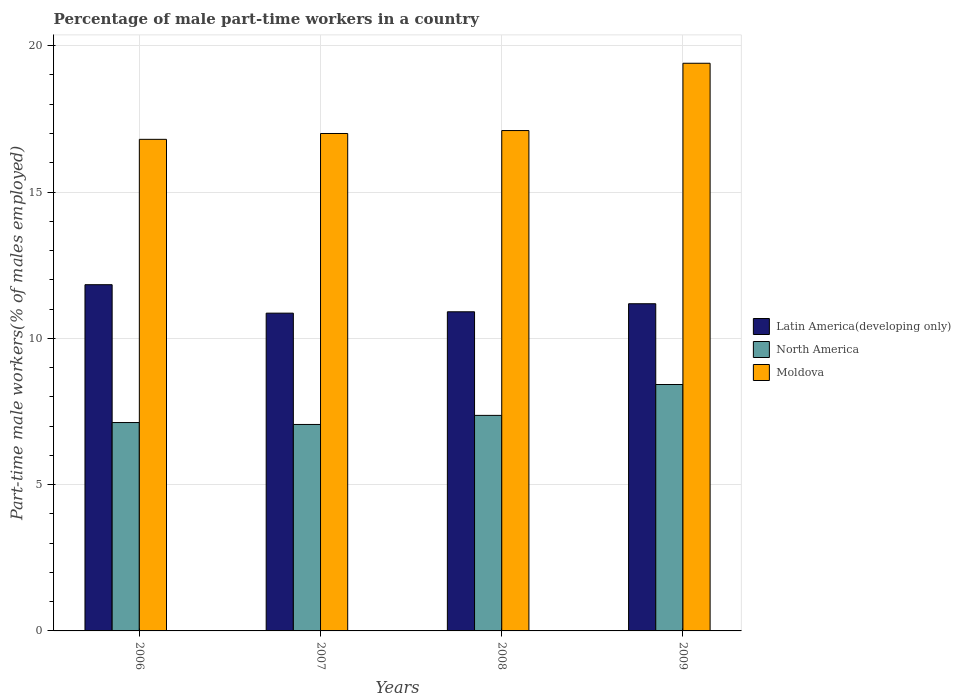What is the percentage of male part-time workers in Moldova in 2006?
Provide a short and direct response. 16.8. Across all years, what is the maximum percentage of male part-time workers in Moldova?
Your response must be concise. 19.4. Across all years, what is the minimum percentage of male part-time workers in Latin America(developing only)?
Ensure brevity in your answer.  10.86. In which year was the percentage of male part-time workers in North America minimum?
Your response must be concise. 2007. What is the total percentage of male part-time workers in North America in the graph?
Offer a very short reply. 29.96. What is the difference between the percentage of male part-time workers in North America in 2006 and that in 2008?
Provide a succinct answer. -0.24. What is the difference between the percentage of male part-time workers in Moldova in 2008 and the percentage of male part-time workers in Latin America(developing only) in 2007?
Your response must be concise. 6.24. What is the average percentage of male part-time workers in North America per year?
Your answer should be very brief. 7.49. In the year 2006, what is the difference between the percentage of male part-time workers in Moldova and percentage of male part-time workers in Latin America(developing only)?
Provide a succinct answer. 4.97. What is the ratio of the percentage of male part-time workers in Moldova in 2006 to that in 2009?
Give a very brief answer. 0.87. Is the difference between the percentage of male part-time workers in Moldova in 2006 and 2009 greater than the difference between the percentage of male part-time workers in Latin America(developing only) in 2006 and 2009?
Your answer should be compact. No. What is the difference between the highest and the second highest percentage of male part-time workers in Moldova?
Your response must be concise. 2.3. What is the difference between the highest and the lowest percentage of male part-time workers in Moldova?
Ensure brevity in your answer.  2.6. Is the sum of the percentage of male part-time workers in North America in 2006 and 2008 greater than the maximum percentage of male part-time workers in Moldova across all years?
Your answer should be compact. No. What does the 1st bar from the left in 2006 represents?
Ensure brevity in your answer.  Latin America(developing only). What does the 3rd bar from the right in 2006 represents?
Give a very brief answer. Latin America(developing only). What is the title of the graph?
Offer a terse response. Percentage of male part-time workers in a country. Does "Europe(developing only)" appear as one of the legend labels in the graph?
Your answer should be compact. No. What is the label or title of the Y-axis?
Ensure brevity in your answer.  Part-time male workers(% of males employed). What is the Part-time male workers(% of males employed) of Latin America(developing only) in 2006?
Give a very brief answer. 11.83. What is the Part-time male workers(% of males employed) in North America in 2006?
Offer a very short reply. 7.12. What is the Part-time male workers(% of males employed) of Moldova in 2006?
Provide a short and direct response. 16.8. What is the Part-time male workers(% of males employed) in Latin America(developing only) in 2007?
Provide a short and direct response. 10.86. What is the Part-time male workers(% of males employed) of North America in 2007?
Make the answer very short. 7.06. What is the Part-time male workers(% of males employed) of Latin America(developing only) in 2008?
Your response must be concise. 10.91. What is the Part-time male workers(% of males employed) in North America in 2008?
Provide a short and direct response. 7.37. What is the Part-time male workers(% of males employed) in Moldova in 2008?
Provide a short and direct response. 17.1. What is the Part-time male workers(% of males employed) in Latin America(developing only) in 2009?
Your answer should be very brief. 11.18. What is the Part-time male workers(% of males employed) in North America in 2009?
Offer a terse response. 8.42. What is the Part-time male workers(% of males employed) of Moldova in 2009?
Provide a succinct answer. 19.4. Across all years, what is the maximum Part-time male workers(% of males employed) in Latin America(developing only)?
Your answer should be compact. 11.83. Across all years, what is the maximum Part-time male workers(% of males employed) of North America?
Ensure brevity in your answer.  8.42. Across all years, what is the maximum Part-time male workers(% of males employed) in Moldova?
Offer a very short reply. 19.4. Across all years, what is the minimum Part-time male workers(% of males employed) in Latin America(developing only)?
Your answer should be compact. 10.86. Across all years, what is the minimum Part-time male workers(% of males employed) of North America?
Give a very brief answer. 7.06. Across all years, what is the minimum Part-time male workers(% of males employed) of Moldova?
Ensure brevity in your answer.  16.8. What is the total Part-time male workers(% of males employed) of Latin America(developing only) in the graph?
Offer a very short reply. 44.78. What is the total Part-time male workers(% of males employed) in North America in the graph?
Your response must be concise. 29.96. What is the total Part-time male workers(% of males employed) of Moldova in the graph?
Give a very brief answer. 70.3. What is the difference between the Part-time male workers(% of males employed) of Latin America(developing only) in 2006 and that in 2007?
Your answer should be very brief. 0.97. What is the difference between the Part-time male workers(% of males employed) of North America in 2006 and that in 2007?
Your answer should be compact. 0.07. What is the difference between the Part-time male workers(% of males employed) in Moldova in 2006 and that in 2007?
Your answer should be compact. -0.2. What is the difference between the Part-time male workers(% of males employed) in Latin America(developing only) in 2006 and that in 2008?
Your answer should be very brief. 0.93. What is the difference between the Part-time male workers(% of males employed) of North America in 2006 and that in 2008?
Your answer should be compact. -0.24. What is the difference between the Part-time male workers(% of males employed) of Moldova in 2006 and that in 2008?
Your answer should be very brief. -0.3. What is the difference between the Part-time male workers(% of males employed) of Latin America(developing only) in 2006 and that in 2009?
Keep it short and to the point. 0.65. What is the difference between the Part-time male workers(% of males employed) of North America in 2006 and that in 2009?
Offer a very short reply. -1.3. What is the difference between the Part-time male workers(% of males employed) in Moldova in 2006 and that in 2009?
Your answer should be very brief. -2.6. What is the difference between the Part-time male workers(% of males employed) in Latin America(developing only) in 2007 and that in 2008?
Offer a terse response. -0.05. What is the difference between the Part-time male workers(% of males employed) in North America in 2007 and that in 2008?
Your answer should be compact. -0.31. What is the difference between the Part-time male workers(% of males employed) in Latin America(developing only) in 2007 and that in 2009?
Your response must be concise. -0.32. What is the difference between the Part-time male workers(% of males employed) in North America in 2007 and that in 2009?
Offer a very short reply. -1.36. What is the difference between the Part-time male workers(% of males employed) in Moldova in 2007 and that in 2009?
Give a very brief answer. -2.4. What is the difference between the Part-time male workers(% of males employed) of Latin America(developing only) in 2008 and that in 2009?
Ensure brevity in your answer.  -0.28. What is the difference between the Part-time male workers(% of males employed) in North America in 2008 and that in 2009?
Provide a short and direct response. -1.05. What is the difference between the Part-time male workers(% of males employed) in Latin America(developing only) in 2006 and the Part-time male workers(% of males employed) in North America in 2007?
Offer a terse response. 4.78. What is the difference between the Part-time male workers(% of males employed) of Latin America(developing only) in 2006 and the Part-time male workers(% of males employed) of Moldova in 2007?
Give a very brief answer. -5.17. What is the difference between the Part-time male workers(% of males employed) of North America in 2006 and the Part-time male workers(% of males employed) of Moldova in 2007?
Ensure brevity in your answer.  -9.88. What is the difference between the Part-time male workers(% of males employed) in Latin America(developing only) in 2006 and the Part-time male workers(% of males employed) in North America in 2008?
Provide a short and direct response. 4.47. What is the difference between the Part-time male workers(% of males employed) in Latin America(developing only) in 2006 and the Part-time male workers(% of males employed) in Moldova in 2008?
Provide a short and direct response. -5.27. What is the difference between the Part-time male workers(% of males employed) in North America in 2006 and the Part-time male workers(% of males employed) in Moldova in 2008?
Give a very brief answer. -9.98. What is the difference between the Part-time male workers(% of males employed) of Latin America(developing only) in 2006 and the Part-time male workers(% of males employed) of North America in 2009?
Provide a succinct answer. 3.41. What is the difference between the Part-time male workers(% of males employed) in Latin America(developing only) in 2006 and the Part-time male workers(% of males employed) in Moldova in 2009?
Your answer should be very brief. -7.57. What is the difference between the Part-time male workers(% of males employed) of North America in 2006 and the Part-time male workers(% of males employed) of Moldova in 2009?
Make the answer very short. -12.28. What is the difference between the Part-time male workers(% of males employed) of Latin America(developing only) in 2007 and the Part-time male workers(% of males employed) of North America in 2008?
Offer a very short reply. 3.49. What is the difference between the Part-time male workers(% of males employed) in Latin America(developing only) in 2007 and the Part-time male workers(% of males employed) in Moldova in 2008?
Offer a very short reply. -6.24. What is the difference between the Part-time male workers(% of males employed) of North America in 2007 and the Part-time male workers(% of males employed) of Moldova in 2008?
Ensure brevity in your answer.  -10.04. What is the difference between the Part-time male workers(% of males employed) of Latin America(developing only) in 2007 and the Part-time male workers(% of males employed) of North America in 2009?
Your answer should be very brief. 2.44. What is the difference between the Part-time male workers(% of males employed) of Latin America(developing only) in 2007 and the Part-time male workers(% of males employed) of Moldova in 2009?
Offer a terse response. -8.54. What is the difference between the Part-time male workers(% of males employed) in North America in 2007 and the Part-time male workers(% of males employed) in Moldova in 2009?
Provide a short and direct response. -12.34. What is the difference between the Part-time male workers(% of males employed) in Latin America(developing only) in 2008 and the Part-time male workers(% of males employed) in North America in 2009?
Give a very brief answer. 2.49. What is the difference between the Part-time male workers(% of males employed) in Latin America(developing only) in 2008 and the Part-time male workers(% of males employed) in Moldova in 2009?
Offer a terse response. -8.49. What is the difference between the Part-time male workers(% of males employed) in North America in 2008 and the Part-time male workers(% of males employed) in Moldova in 2009?
Provide a succinct answer. -12.03. What is the average Part-time male workers(% of males employed) of Latin America(developing only) per year?
Ensure brevity in your answer.  11.2. What is the average Part-time male workers(% of males employed) in North America per year?
Offer a very short reply. 7.49. What is the average Part-time male workers(% of males employed) in Moldova per year?
Your answer should be compact. 17.57. In the year 2006, what is the difference between the Part-time male workers(% of males employed) of Latin America(developing only) and Part-time male workers(% of males employed) of North America?
Your answer should be compact. 4.71. In the year 2006, what is the difference between the Part-time male workers(% of males employed) in Latin America(developing only) and Part-time male workers(% of males employed) in Moldova?
Offer a terse response. -4.97. In the year 2006, what is the difference between the Part-time male workers(% of males employed) of North America and Part-time male workers(% of males employed) of Moldova?
Provide a succinct answer. -9.68. In the year 2007, what is the difference between the Part-time male workers(% of males employed) of Latin America(developing only) and Part-time male workers(% of males employed) of North America?
Provide a succinct answer. 3.8. In the year 2007, what is the difference between the Part-time male workers(% of males employed) in Latin America(developing only) and Part-time male workers(% of males employed) in Moldova?
Offer a terse response. -6.14. In the year 2007, what is the difference between the Part-time male workers(% of males employed) in North America and Part-time male workers(% of males employed) in Moldova?
Offer a very short reply. -9.94. In the year 2008, what is the difference between the Part-time male workers(% of males employed) in Latin America(developing only) and Part-time male workers(% of males employed) in North America?
Your response must be concise. 3.54. In the year 2008, what is the difference between the Part-time male workers(% of males employed) in Latin America(developing only) and Part-time male workers(% of males employed) in Moldova?
Offer a terse response. -6.19. In the year 2008, what is the difference between the Part-time male workers(% of males employed) in North America and Part-time male workers(% of males employed) in Moldova?
Make the answer very short. -9.73. In the year 2009, what is the difference between the Part-time male workers(% of males employed) of Latin America(developing only) and Part-time male workers(% of males employed) of North America?
Keep it short and to the point. 2.76. In the year 2009, what is the difference between the Part-time male workers(% of males employed) of Latin America(developing only) and Part-time male workers(% of males employed) of Moldova?
Keep it short and to the point. -8.22. In the year 2009, what is the difference between the Part-time male workers(% of males employed) of North America and Part-time male workers(% of males employed) of Moldova?
Give a very brief answer. -10.98. What is the ratio of the Part-time male workers(% of males employed) in Latin America(developing only) in 2006 to that in 2007?
Your answer should be compact. 1.09. What is the ratio of the Part-time male workers(% of males employed) in North America in 2006 to that in 2007?
Keep it short and to the point. 1.01. What is the ratio of the Part-time male workers(% of males employed) of Latin America(developing only) in 2006 to that in 2008?
Provide a short and direct response. 1.08. What is the ratio of the Part-time male workers(% of males employed) of North America in 2006 to that in 2008?
Give a very brief answer. 0.97. What is the ratio of the Part-time male workers(% of males employed) in Moldova in 2006 to that in 2008?
Offer a terse response. 0.98. What is the ratio of the Part-time male workers(% of males employed) of Latin America(developing only) in 2006 to that in 2009?
Make the answer very short. 1.06. What is the ratio of the Part-time male workers(% of males employed) of North America in 2006 to that in 2009?
Provide a short and direct response. 0.85. What is the ratio of the Part-time male workers(% of males employed) of Moldova in 2006 to that in 2009?
Offer a terse response. 0.87. What is the ratio of the Part-time male workers(% of males employed) of Latin America(developing only) in 2007 to that in 2008?
Ensure brevity in your answer.  1. What is the ratio of the Part-time male workers(% of males employed) in North America in 2007 to that in 2008?
Your answer should be compact. 0.96. What is the ratio of the Part-time male workers(% of males employed) in Latin America(developing only) in 2007 to that in 2009?
Provide a short and direct response. 0.97. What is the ratio of the Part-time male workers(% of males employed) in North America in 2007 to that in 2009?
Keep it short and to the point. 0.84. What is the ratio of the Part-time male workers(% of males employed) in Moldova in 2007 to that in 2009?
Your response must be concise. 0.88. What is the ratio of the Part-time male workers(% of males employed) in Latin America(developing only) in 2008 to that in 2009?
Your answer should be compact. 0.98. What is the ratio of the Part-time male workers(% of males employed) in North America in 2008 to that in 2009?
Ensure brevity in your answer.  0.87. What is the ratio of the Part-time male workers(% of males employed) of Moldova in 2008 to that in 2009?
Your answer should be very brief. 0.88. What is the difference between the highest and the second highest Part-time male workers(% of males employed) in Latin America(developing only)?
Make the answer very short. 0.65. What is the difference between the highest and the second highest Part-time male workers(% of males employed) in North America?
Make the answer very short. 1.05. What is the difference between the highest and the lowest Part-time male workers(% of males employed) of Latin America(developing only)?
Ensure brevity in your answer.  0.97. What is the difference between the highest and the lowest Part-time male workers(% of males employed) in North America?
Your answer should be compact. 1.36. What is the difference between the highest and the lowest Part-time male workers(% of males employed) in Moldova?
Make the answer very short. 2.6. 